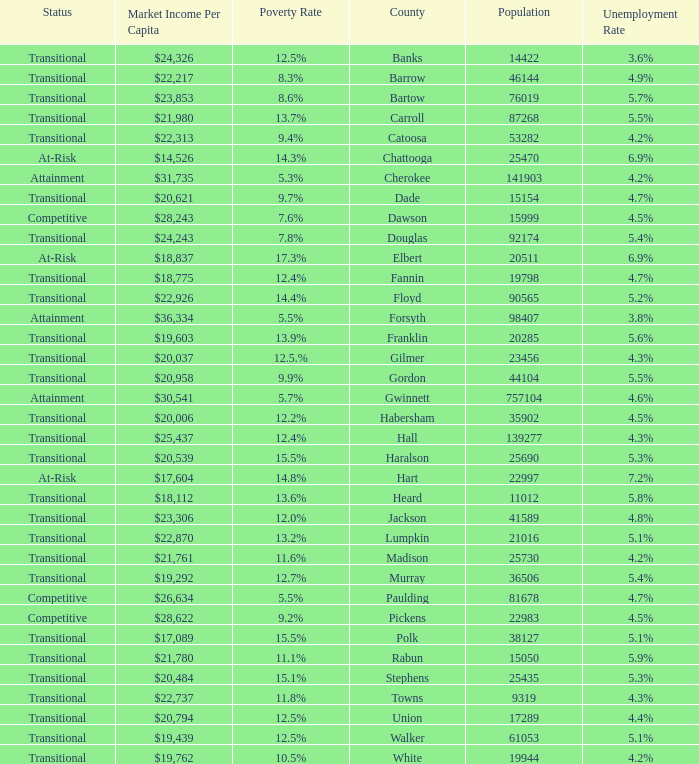What is the status of the county that has a 17.3% poverty rate? At-Risk. 